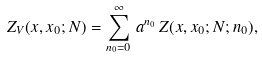Convert formula to latex. <formula><loc_0><loc_0><loc_500><loc_500>Z _ { V } ( x , x _ { 0 } ; N ) = \sum _ { n _ { 0 } = 0 } ^ { \infty } \, a ^ { n _ { 0 } } \, Z ( x , x _ { 0 } ; N ; n _ { 0 } ) ,</formula> 